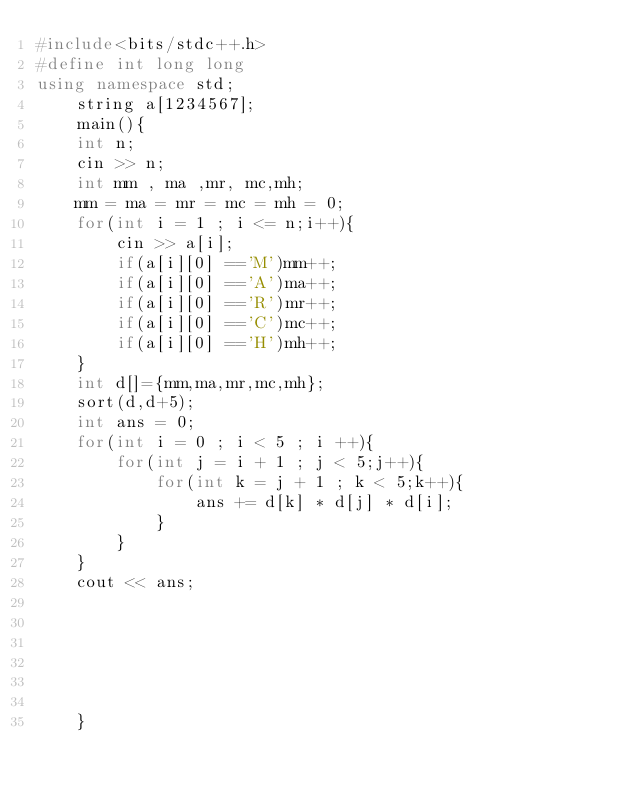<code> <loc_0><loc_0><loc_500><loc_500><_C++_>#include<bits/stdc++.h>
#define int long long
using namespace std;
    string a[1234567];
    main(){
    int n;
    cin >> n;
    int mm , ma ,mr, mc,mh;
    mm = ma = mr = mc = mh = 0;
    for(int i = 1 ; i <= n;i++){
        cin >> a[i];
        if(a[i][0] =='M')mm++;
        if(a[i][0] =='A')ma++;
        if(a[i][0] =='R')mr++;
        if(a[i][0] =='C')mc++;
        if(a[i][0] =='H')mh++;
    }
    int d[]={mm,ma,mr,mc,mh};
    sort(d,d+5);
    int ans = 0;
    for(int i = 0 ; i < 5 ; i ++){
        for(int j = i + 1 ; j < 5;j++){
            for(int k = j + 1 ; k < 5;k++){
                ans += d[k] * d[j] * d[i];
            }
        }
    }
    cout << ans;






    }
</code> 